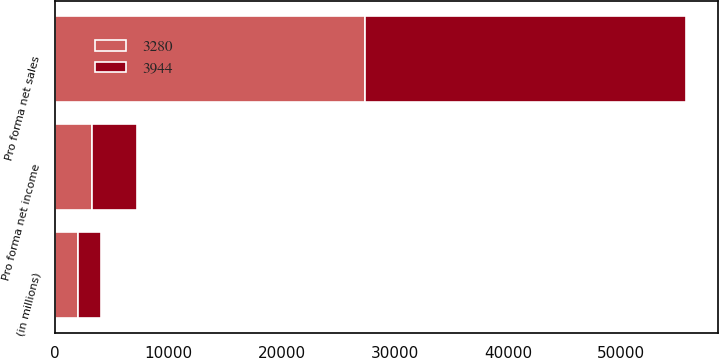Convert chart to OTSL. <chart><loc_0><loc_0><loc_500><loc_500><stacked_bar_chart><ecel><fcel>(in millions)<fcel>Pro forma net sales<fcel>Pro forma net income<nl><fcel>3944<fcel>2015<fcel>28369<fcel>3944<nl><fcel>3280<fcel>2014<fcel>27380<fcel>3280<nl></chart> 